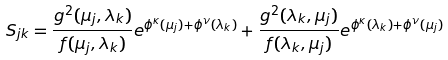<formula> <loc_0><loc_0><loc_500><loc_500>S _ { j k } = \frac { g ^ { 2 } ( \mu _ { j } , \lambda _ { k } ) } { f ( \mu _ { j } , \lambda _ { k } ) } e ^ { \phi ^ { \kappa } ( \mu _ { j } ) + \phi ^ { \nu } ( \lambda _ { k } ) } + \frac { g ^ { 2 } ( \lambda _ { k } , \mu _ { j } ) } { f ( \lambda _ { k } , \mu _ { j } ) } e ^ { \phi ^ { \kappa } ( \lambda _ { k } ) + \phi ^ { \nu } ( \mu _ { j } ) }</formula> 